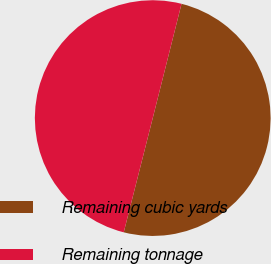<chart> <loc_0><loc_0><loc_500><loc_500><pie_chart><fcel>Remaining cubic yards<fcel>Remaining tonnage<nl><fcel>50.03%<fcel>49.97%<nl></chart> 